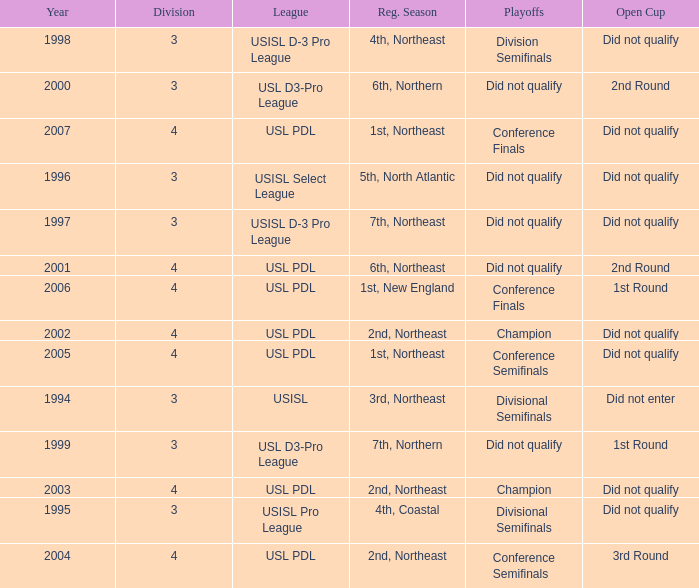Name the playoffs for  usisl select league Did not qualify. 